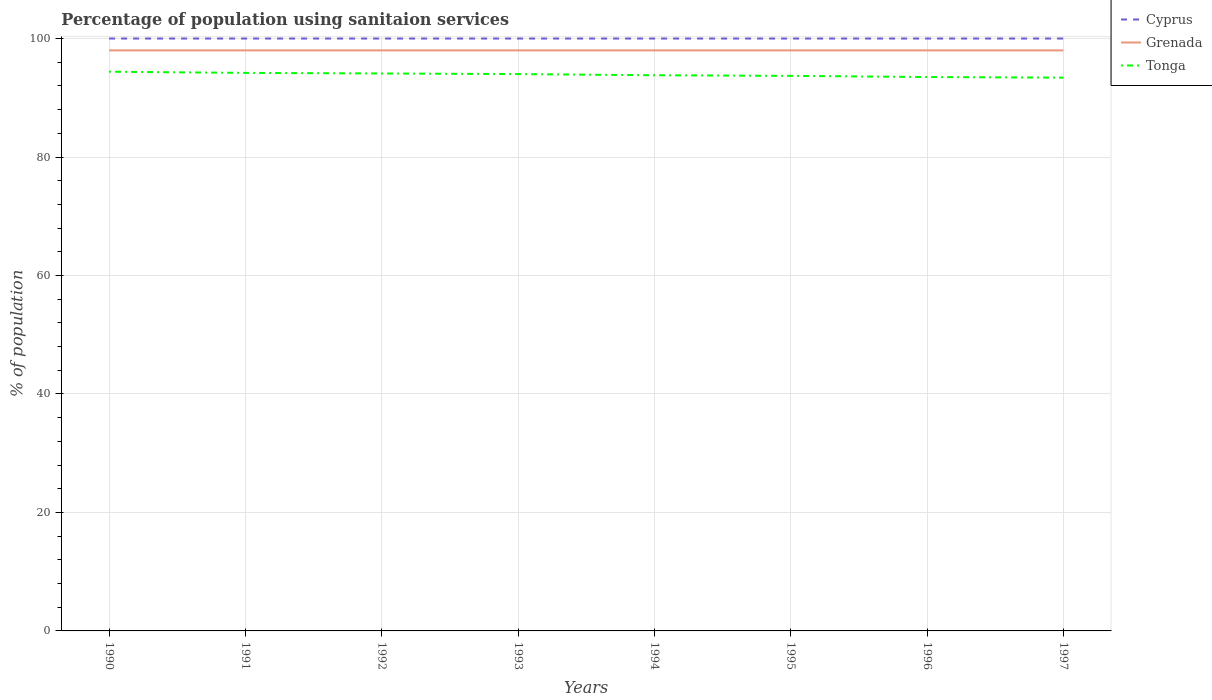Across all years, what is the maximum percentage of population using sanitaion services in Grenada?
Your answer should be compact. 98. What is the total percentage of population using sanitaion services in Cyprus in the graph?
Make the answer very short. 0. Is the percentage of population using sanitaion services in Tonga strictly greater than the percentage of population using sanitaion services in Cyprus over the years?
Provide a short and direct response. Yes. How many years are there in the graph?
Your answer should be very brief. 8. Are the values on the major ticks of Y-axis written in scientific E-notation?
Your answer should be very brief. No. Does the graph contain any zero values?
Give a very brief answer. No. Where does the legend appear in the graph?
Your response must be concise. Top right. What is the title of the graph?
Your response must be concise. Percentage of population using sanitaion services. What is the label or title of the Y-axis?
Give a very brief answer. % of population. What is the % of population in Grenada in 1990?
Give a very brief answer. 98. What is the % of population in Tonga in 1990?
Give a very brief answer. 94.4. What is the % of population in Cyprus in 1991?
Provide a short and direct response. 100. What is the % of population of Grenada in 1991?
Give a very brief answer. 98. What is the % of population in Tonga in 1991?
Offer a terse response. 94.2. What is the % of population in Grenada in 1992?
Your answer should be compact. 98. What is the % of population of Tonga in 1992?
Offer a terse response. 94.1. What is the % of population of Cyprus in 1993?
Offer a terse response. 100. What is the % of population in Grenada in 1993?
Offer a very short reply. 98. What is the % of population in Tonga in 1993?
Your response must be concise. 94. What is the % of population of Cyprus in 1994?
Your answer should be very brief. 100. What is the % of population of Grenada in 1994?
Make the answer very short. 98. What is the % of population in Tonga in 1994?
Ensure brevity in your answer.  93.8. What is the % of population of Cyprus in 1995?
Your response must be concise. 100. What is the % of population of Tonga in 1995?
Your answer should be very brief. 93.7. What is the % of population of Grenada in 1996?
Provide a short and direct response. 98. What is the % of population in Tonga in 1996?
Offer a terse response. 93.5. What is the % of population in Grenada in 1997?
Your answer should be compact. 98. What is the % of population in Tonga in 1997?
Your answer should be very brief. 93.4. Across all years, what is the maximum % of population of Cyprus?
Your answer should be compact. 100. Across all years, what is the maximum % of population of Tonga?
Give a very brief answer. 94.4. Across all years, what is the minimum % of population in Grenada?
Offer a terse response. 98. Across all years, what is the minimum % of population of Tonga?
Give a very brief answer. 93.4. What is the total % of population in Cyprus in the graph?
Keep it short and to the point. 800. What is the total % of population in Grenada in the graph?
Offer a terse response. 784. What is the total % of population of Tonga in the graph?
Ensure brevity in your answer.  751.1. What is the difference between the % of population in Cyprus in 1990 and that in 1991?
Your response must be concise. 0. What is the difference between the % of population in Grenada in 1990 and that in 1993?
Offer a terse response. 0. What is the difference between the % of population of Tonga in 1990 and that in 1993?
Ensure brevity in your answer.  0.4. What is the difference between the % of population of Grenada in 1990 and that in 1994?
Provide a succinct answer. 0. What is the difference between the % of population of Grenada in 1990 and that in 1995?
Ensure brevity in your answer.  0. What is the difference between the % of population of Tonga in 1990 and that in 1995?
Your answer should be compact. 0.7. What is the difference between the % of population of Cyprus in 1990 and that in 1996?
Your answer should be compact. 0. What is the difference between the % of population of Grenada in 1990 and that in 1996?
Your answer should be very brief. 0. What is the difference between the % of population of Tonga in 1990 and that in 1996?
Offer a terse response. 0.9. What is the difference between the % of population in Grenada in 1990 and that in 1997?
Offer a terse response. 0. What is the difference between the % of population in Grenada in 1991 and that in 1992?
Offer a terse response. 0. What is the difference between the % of population of Tonga in 1991 and that in 1992?
Your answer should be compact. 0.1. What is the difference between the % of population of Cyprus in 1991 and that in 1993?
Give a very brief answer. 0. What is the difference between the % of population of Grenada in 1991 and that in 1993?
Offer a terse response. 0. What is the difference between the % of population in Cyprus in 1991 and that in 1994?
Offer a terse response. 0. What is the difference between the % of population in Grenada in 1991 and that in 1995?
Your answer should be compact. 0. What is the difference between the % of population of Tonga in 1991 and that in 1995?
Ensure brevity in your answer.  0.5. What is the difference between the % of population in Cyprus in 1991 and that in 1996?
Your answer should be very brief. 0. What is the difference between the % of population in Grenada in 1991 and that in 1996?
Offer a terse response. 0. What is the difference between the % of population of Tonga in 1991 and that in 1996?
Your answer should be very brief. 0.7. What is the difference between the % of population of Grenada in 1992 and that in 1993?
Provide a short and direct response. 0. What is the difference between the % of population of Tonga in 1992 and that in 1993?
Give a very brief answer. 0.1. What is the difference between the % of population in Tonga in 1992 and that in 1994?
Your answer should be compact. 0.3. What is the difference between the % of population in Tonga in 1992 and that in 1995?
Provide a succinct answer. 0.4. What is the difference between the % of population of Cyprus in 1992 and that in 1996?
Offer a very short reply. 0. What is the difference between the % of population of Tonga in 1992 and that in 1996?
Keep it short and to the point. 0.6. What is the difference between the % of population of Cyprus in 1992 and that in 1997?
Offer a very short reply. 0. What is the difference between the % of population of Tonga in 1992 and that in 1997?
Offer a terse response. 0.7. What is the difference between the % of population in Cyprus in 1993 and that in 1994?
Provide a succinct answer. 0. What is the difference between the % of population of Tonga in 1993 and that in 1994?
Give a very brief answer. 0.2. What is the difference between the % of population of Grenada in 1993 and that in 1995?
Keep it short and to the point. 0. What is the difference between the % of population in Cyprus in 1993 and that in 1997?
Make the answer very short. 0. What is the difference between the % of population of Grenada in 1993 and that in 1997?
Give a very brief answer. 0. What is the difference between the % of population in Tonga in 1993 and that in 1997?
Keep it short and to the point. 0.6. What is the difference between the % of population of Grenada in 1994 and that in 1995?
Your answer should be compact. 0. What is the difference between the % of population in Tonga in 1994 and that in 1995?
Make the answer very short. 0.1. What is the difference between the % of population in Cyprus in 1994 and that in 1996?
Your answer should be very brief. 0. What is the difference between the % of population of Tonga in 1994 and that in 1996?
Your response must be concise. 0.3. What is the difference between the % of population of Cyprus in 1994 and that in 1997?
Offer a very short reply. 0. What is the difference between the % of population in Grenada in 1995 and that in 1996?
Your response must be concise. 0. What is the difference between the % of population of Cyprus in 1995 and that in 1997?
Your answer should be very brief. 0. What is the difference between the % of population in Tonga in 1995 and that in 1997?
Give a very brief answer. 0.3. What is the difference between the % of population in Grenada in 1996 and that in 1997?
Your answer should be very brief. 0. What is the difference between the % of population in Cyprus in 1990 and the % of population in Tonga in 1991?
Your answer should be very brief. 5.8. What is the difference between the % of population in Cyprus in 1990 and the % of population in Grenada in 1992?
Your answer should be compact. 2. What is the difference between the % of population in Grenada in 1990 and the % of population in Tonga in 1992?
Offer a very short reply. 3.9. What is the difference between the % of population in Cyprus in 1990 and the % of population in Tonga in 1993?
Give a very brief answer. 6. What is the difference between the % of population in Grenada in 1990 and the % of population in Tonga in 1993?
Your answer should be compact. 4. What is the difference between the % of population in Cyprus in 1990 and the % of population in Grenada in 1994?
Offer a terse response. 2. What is the difference between the % of population of Cyprus in 1990 and the % of population of Tonga in 1994?
Offer a terse response. 6.2. What is the difference between the % of population of Grenada in 1990 and the % of population of Tonga in 1994?
Give a very brief answer. 4.2. What is the difference between the % of population of Cyprus in 1990 and the % of population of Tonga in 1995?
Offer a terse response. 6.3. What is the difference between the % of population of Cyprus in 1990 and the % of population of Tonga in 1996?
Your answer should be compact. 6.5. What is the difference between the % of population in Cyprus in 1990 and the % of population in Grenada in 1997?
Ensure brevity in your answer.  2. What is the difference between the % of population of Grenada in 1990 and the % of population of Tonga in 1997?
Offer a terse response. 4.6. What is the difference between the % of population of Cyprus in 1991 and the % of population of Tonga in 1992?
Your answer should be very brief. 5.9. What is the difference between the % of population in Grenada in 1991 and the % of population in Tonga in 1992?
Ensure brevity in your answer.  3.9. What is the difference between the % of population of Cyprus in 1991 and the % of population of Grenada in 1993?
Give a very brief answer. 2. What is the difference between the % of population of Cyprus in 1991 and the % of population of Tonga in 1993?
Ensure brevity in your answer.  6. What is the difference between the % of population in Cyprus in 1991 and the % of population in Grenada in 1994?
Make the answer very short. 2. What is the difference between the % of population in Cyprus in 1991 and the % of population in Tonga in 1994?
Your response must be concise. 6.2. What is the difference between the % of population of Grenada in 1991 and the % of population of Tonga in 1994?
Offer a very short reply. 4.2. What is the difference between the % of population of Cyprus in 1991 and the % of population of Tonga in 1995?
Your answer should be compact. 6.3. What is the difference between the % of population in Cyprus in 1991 and the % of population in Tonga in 1996?
Offer a very short reply. 6.5. What is the difference between the % of population in Grenada in 1991 and the % of population in Tonga in 1996?
Provide a short and direct response. 4.5. What is the difference between the % of population in Cyprus in 1991 and the % of population in Grenada in 1997?
Give a very brief answer. 2. What is the difference between the % of population in Cyprus in 1991 and the % of population in Tonga in 1997?
Provide a succinct answer. 6.6. What is the difference between the % of population in Cyprus in 1992 and the % of population in Tonga in 1993?
Provide a short and direct response. 6. What is the difference between the % of population of Grenada in 1992 and the % of population of Tonga in 1993?
Ensure brevity in your answer.  4. What is the difference between the % of population in Cyprus in 1992 and the % of population in Grenada in 1994?
Offer a very short reply. 2. What is the difference between the % of population in Grenada in 1992 and the % of population in Tonga in 1994?
Your answer should be very brief. 4.2. What is the difference between the % of population of Cyprus in 1992 and the % of population of Grenada in 1995?
Your answer should be very brief. 2. What is the difference between the % of population of Grenada in 1992 and the % of population of Tonga in 1995?
Ensure brevity in your answer.  4.3. What is the difference between the % of population of Cyprus in 1992 and the % of population of Tonga in 1996?
Give a very brief answer. 6.5. What is the difference between the % of population in Grenada in 1992 and the % of population in Tonga in 1996?
Keep it short and to the point. 4.5. What is the difference between the % of population in Cyprus in 1992 and the % of population in Grenada in 1997?
Offer a very short reply. 2. What is the difference between the % of population of Grenada in 1992 and the % of population of Tonga in 1997?
Provide a short and direct response. 4.6. What is the difference between the % of population of Cyprus in 1993 and the % of population of Tonga in 1994?
Offer a terse response. 6.2. What is the difference between the % of population in Grenada in 1993 and the % of population in Tonga in 1994?
Offer a very short reply. 4.2. What is the difference between the % of population of Cyprus in 1993 and the % of population of Tonga in 1995?
Ensure brevity in your answer.  6.3. What is the difference between the % of population in Cyprus in 1993 and the % of population in Grenada in 1996?
Offer a very short reply. 2. What is the difference between the % of population in Cyprus in 1993 and the % of population in Tonga in 1996?
Give a very brief answer. 6.5. What is the difference between the % of population in Cyprus in 1993 and the % of population in Tonga in 1997?
Your answer should be compact. 6.6. What is the difference between the % of population of Grenada in 1993 and the % of population of Tonga in 1997?
Offer a very short reply. 4.6. What is the difference between the % of population of Cyprus in 1994 and the % of population of Grenada in 1995?
Your response must be concise. 2. What is the difference between the % of population in Grenada in 1994 and the % of population in Tonga in 1995?
Offer a terse response. 4.3. What is the difference between the % of population of Cyprus in 1994 and the % of population of Tonga in 1996?
Your answer should be very brief. 6.5. What is the difference between the % of population of Cyprus in 1994 and the % of population of Grenada in 1997?
Your response must be concise. 2. What is the difference between the % of population in Cyprus in 1995 and the % of population in Tonga in 1996?
Provide a succinct answer. 6.5. What is the difference between the % of population in Grenada in 1995 and the % of population in Tonga in 1996?
Provide a short and direct response. 4.5. What is the difference between the % of population in Cyprus in 1996 and the % of population in Grenada in 1997?
Make the answer very short. 2. What is the difference between the % of population in Cyprus in 1996 and the % of population in Tonga in 1997?
Your answer should be very brief. 6.6. What is the average % of population in Grenada per year?
Make the answer very short. 98. What is the average % of population of Tonga per year?
Ensure brevity in your answer.  93.89. In the year 1990, what is the difference between the % of population of Cyprus and % of population of Grenada?
Provide a short and direct response. 2. In the year 1990, what is the difference between the % of population in Cyprus and % of population in Tonga?
Your answer should be compact. 5.6. In the year 1991, what is the difference between the % of population in Cyprus and % of population in Grenada?
Your answer should be very brief. 2. In the year 1991, what is the difference between the % of population in Cyprus and % of population in Tonga?
Your answer should be very brief. 5.8. In the year 1992, what is the difference between the % of population of Cyprus and % of population of Grenada?
Offer a terse response. 2. In the year 1992, what is the difference between the % of population in Cyprus and % of population in Tonga?
Offer a terse response. 5.9. In the year 1992, what is the difference between the % of population of Grenada and % of population of Tonga?
Your answer should be very brief. 3.9. In the year 1993, what is the difference between the % of population of Cyprus and % of population of Grenada?
Provide a succinct answer. 2. In the year 1993, what is the difference between the % of population in Cyprus and % of population in Tonga?
Give a very brief answer. 6. In the year 1993, what is the difference between the % of population of Grenada and % of population of Tonga?
Provide a succinct answer. 4. In the year 1994, what is the difference between the % of population of Cyprus and % of population of Grenada?
Your answer should be very brief. 2. In the year 1994, what is the difference between the % of population of Cyprus and % of population of Tonga?
Give a very brief answer. 6.2. In the year 1995, what is the difference between the % of population in Cyprus and % of population in Grenada?
Provide a short and direct response. 2. In the year 1995, what is the difference between the % of population in Cyprus and % of population in Tonga?
Give a very brief answer. 6.3. In the year 1995, what is the difference between the % of population in Grenada and % of population in Tonga?
Your answer should be very brief. 4.3. In the year 1996, what is the difference between the % of population in Grenada and % of population in Tonga?
Offer a terse response. 4.5. What is the ratio of the % of population in Grenada in 1990 to that in 1992?
Offer a terse response. 1. What is the ratio of the % of population of Tonga in 1990 to that in 1992?
Ensure brevity in your answer.  1. What is the ratio of the % of population of Cyprus in 1990 to that in 1993?
Provide a succinct answer. 1. What is the ratio of the % of population of Tonga in 1990 to that in 1993?
Your answer should be compact. 1. What is the ratio of the % of population in Cyprus in 1990 to that in 1994?
Your response must be concise. 1. What is the ratio of the % of population in Grenada in 1990 to that in 1994?
Offer a terse response. 1. What is the ratio of the % of population in Tonga in 1990 to that in 1994?
Your answer should be compact. 1.01. What is the ratio of the % of population of Grenada in 1990 to that in 1995?
Give a very brief answer. 1. What is the ratio of the % of population in Tonga in 1990 to that in 1995?
Your response must be concise. 1.01. What is the ratio of the % of population of Tonga in 1990 to that in 1996?
Your response must be concise. 1.01. What is the ratio of the % of population of Grenada in 1990 to that in 1997?
Your response must be concise. 1. What is the ratio of the % of population of Tonga in 1990 to that in 1997?
Your response must be concise. 1.01. What is the ratio of the % of population of Cyprus in 1991 to that in 1992?
Offer a very short reply. 1. What is the ratio of the % of population in Tonga in 1991 to that in 1993?
Ensure brevity in your answer.  1. What is the ratio of the % of population in Grenada in 1991 to that in 1995?
Your response must be concise. 1. What is the ratio of the % of population in Tonga in 1991 to that in 1995?
Your answer should be very brief. 1.01. What is the ratio of the % of population in Cyprus in 1991 to that in 1996?
Ensure brevity in your answer.  1. What is the ratio of the % of population in Grenada in 1991 to that in 1996?
Provide a short and direct response. 1. What is the ratio of the % of population of Tonga in 1991 to that in 1996?
Offer a very short reply. 1.01. What is the ratio of the % of population of Grenada in 1991 to that in 1997?
Give a very brief answer. 1. What is the ratio of the % of population of Tonga in 1991 to that in 1997?
Offer a terse response. 1.01. What is the ratio of the % of population of Grenada in 1992 to that in 1994?
Offer a terse response. 1. What is the ratio of the % of population of Tonga in 1992 to that in 1994?
Your answer should be compact. 1. What is the ratio of the % of population of Cyprus in 1992 to that in 1995?
Keep it short and to the point. 1. What is the ratio of the % of population in Grenada in 1992 to that in 1995?
Give a very brief answer. 1. What is the ratio of the % of population in Tonga in 1992 to that in 1995?
Provide a short and direct response. 1. What is the ratio of the % of population in Cyprus in 1992 to that in 1996?
Offer a terse response. 1. What is the ratio of the % of population in Tonga in 1992 to that in 1996?
Keep it short and to the point. 1.01. What is the ratio of the % of population of Cyprus in 1992 to that in 1997?
Provide a succinct answer. 1. What is the ratio of the % of population of Tonga in 1992 to that in 1997?
Offer a very short reply. 1.01. What is the ratio of the % of population in Cyprus in 1993 to that in 1994?
Keep it short and to the point. 1. What is the ratio of the % of population of Grenada in 1993 to that in 1994?
Provide a succinct answer. 1. What is the ratio of the % of population in Cyprus in 1993 to that in 1995?
Your answer should be very brief. 1. What is the ratio of the % of population in Grenada in 1993 to that in 1995?
Provide a succinct answer. 1. What is the ratio of the % of population in Tonga in 1993 to that in 1995?
Your answer should be very brief. 1. What is the ratio of the % of population of Cyprus in 1993 to that in 1997?
Keep it short and to the point. 1. What is the ratio of the % of population of Grenada in 1993 to that in 1997?
Your response must be concise. 1. What is the ratio of the % of population in Tonga in 1993 to that in 1997?
Offer a very short reply. 1.01. What is the ratio of the % of population in Tonga in 1994 to that in 1995?
Keep it short and to the point. 1. What is the ratio of the % of population in Grenada in 1994 to that in 1996?
Offer a very short reply. 1. What is the ratio of the % of population in Tonga in 1994 to that in 1996?
Offer a terse response. 1. What is the ratio of the % of population in Grenada in 1994 to that in 1997?
Your response must be concise. 1. What is the ratio of the % of population in Cyprus in 1995 to that in 1996?
Your answer should be very brief. 1. What is the ratio of the % of population in Cyprus in 1995 to that in 1997?
Provide a succinct answer. 1. What is the ratio of the % of population of Cyprus in 1996 to that in 1997?
Provide a succinct answer. 1. What is the ratio of the % of population of Tonga in 1996 to that in 1997?
Give a very brief answer. 1. What is the difference between the highest and the lowest % of population in Tonga?
Provide a succinct answer. 1. 